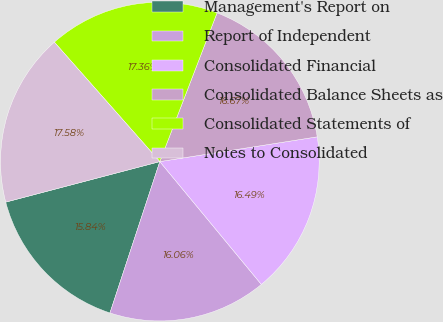Convert chart. <chart><loc_0><loc_0><loc_500><loc_500><pie_chart><fcel>Management's Report on<fcel>Report of Independent<fcel>Consolidated Financial<fcel>Consolidated Balance Sheets as<fcel>Consolidated Statements of<fcel>Notes to Consolidated<nl><fcel>15.84%<fcel>16.06%<fcel>16.49%<fcel>16.67%<fcel>17.36%<fcel>17.58%<nl></chart> 